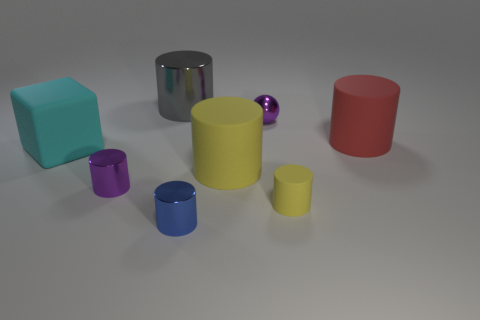Subtract all large yellow cylinders. How many cylinders are left? 5 Subtract all yellow cylinders. How many cylinders are left? 4 Subtract all gray cylinders. Subtract all purple spheres. How many cylinders are left? 5 Add 1 small blue metallic objects. How many objects exist? 9 Subtract all cylinders. How many objects are left? 2 Add 3 yellow cylinders. How many yellow cylinders exist? 5 Subtract 0 yellow cubes. How many objects are left? 8 Subtract all large yellow rubber things. Subtract all large red objects. How many objects are left? 6 Add 5 small blue cylinders. How many small blue cylinders are left? 6 